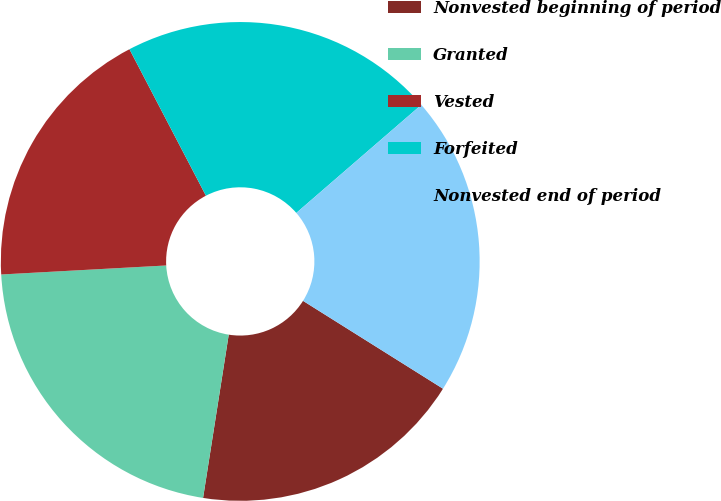Convert chart to OTSL. <chart><loc_0><loc_0><loc_500><loc_500><pie_chart><fcel>Nonvested beginning of period<fcel>Granted<fcel>Vested<fcel>Forfeited<fcel>Nonvested end of period<nl><fcel>18.56%<fcel>21.65%<fcel>18.21%<fcel>21.31%<fcel>20.27%<nl></chart> 